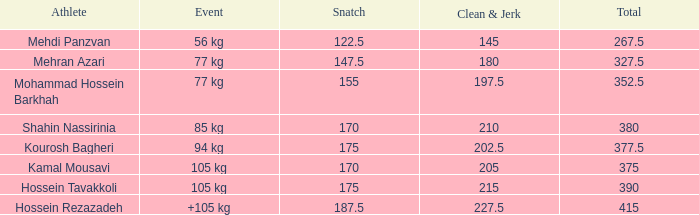What is the overall count of occurrences with a +105 kg event and a clean & jerk under 227.5? 0.0. 